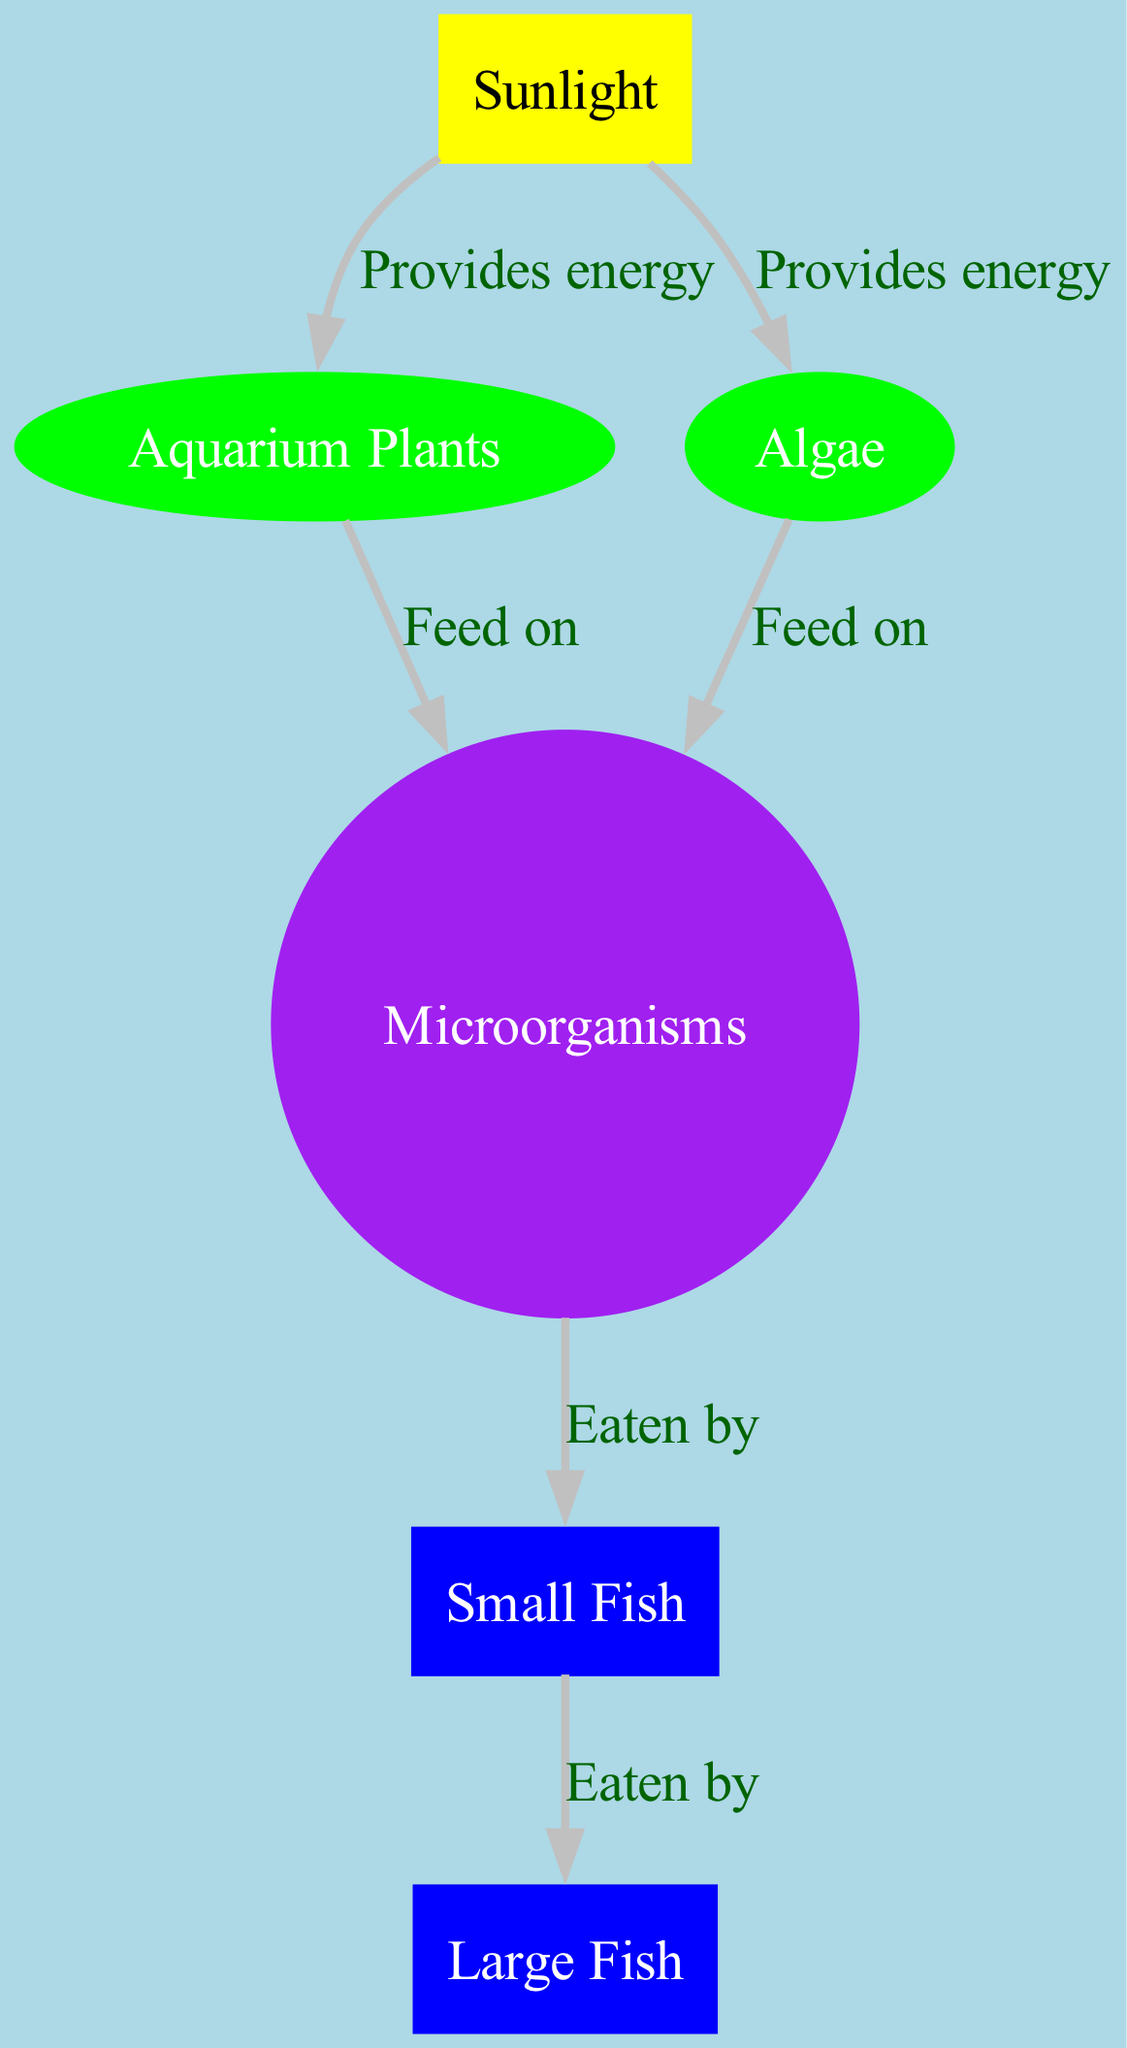What are the main producers in the aquarium food chain? The main producers are organisms that create energy from sunlight. In this diagram, the producers are the "Aquarium Plants" and "Algae," which receive energy directly from "Sunlight."
Answer: Aquarium Plants, Algae How many nodes are present in the diagram? The diagram contains six nodes: "Sunlight," "Aquarium Plants," "Algae," "Microorganisms," "Small Fish," and "Large Fish." This count includes all the unique entities involved in the food chain.
Answer: 6 What do "Aquarium Plants" feed on? "Aquarium Plants" are fed upon by "Microorganisms," as indicated in the relationships in the diagram. They are a source of food for these microorganisms.
Answer: Microorganisms Which organism is directly eaten by "Large Fish"? According to the relationships illustrated in the diagram, "Large Fish" directly eats "Small Fish." This is a one-step connection in the food chain.
Answer: Small Fish What is the role of "Sunlight" in the aquarium food chain? "Sunlight" serves as the primary energy source for the producers in the diagram, specifically "Aquarium Plants" and "Algae." It provides the energy needed for their growth.
Answer: Provides energy How many edges connect the nodes in the diagram? There are six edges in the diagram, each representing the relationships among the different nodes. This includes all feeding and energy transfer relationships.
Answer: 6 Who feeds on "Algae"? The "Microorganisms" are shown to feed on "Algae." This relationship is illustrated in the diagram as a direct feeding connection between these two nodes.
Answer: Microorganisms What is the energy source for "Microorganisms"? The energy source for "Microorganisms" comes from both "Aquarium Plants" and "Algae," as they feed on these producers for their energy needs, as indicated in the edges of the diagram.
Answer: Aquarium Plants, Algae How are "Small Fish" related to "Microorganisms"? "Microorganisms" are a food source for "Small Fish," as shown in the diagram by the direct relationship indicating that "Small Fish" eat "Microorganisms." This demonstrates a predator-prey relationship.
Answer: Eaten by 